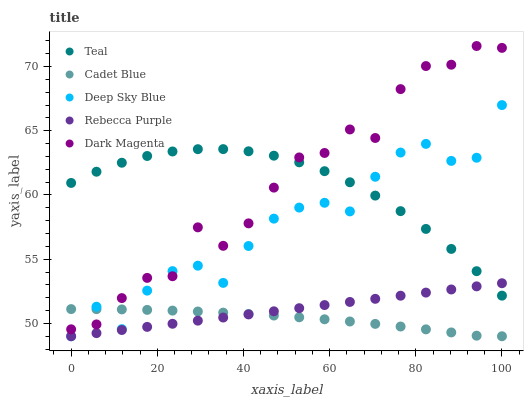Does Cadet Blue have the minimum area under the curve?
Answer yes or no. Yes. Does Dark Magenta have the maximum area under the curve?
Answer yes or no. Yes. Does Deep Sky Blue have the minimum area under the curve?
Answer yes or no. No. Does Deep Sky Blue have the maximum area under the curve?
Answer yes or no. No. Is Rebecca Purple the smoothest?
Answer yes or no. Yes. Is Dark Magenta the roughest?
Answer yes or no. Yes. Is Cadet Blue the smoothest?
Answer yes or no. No. Is Cadet Blue the roughest?
Answer yes or no. No. Does Cadet Blue have the lowest value?
Answer yes or no. Yes. Does Teal have the lowest value?
Answer yes or no. No. Does Dark Magenta have the highest value?
Answer yes or no. Yes. Does Deep Sky Blue have the highest value?
Answer yes or no. No. Is Cadet Blue less than Teal?
Answer yes or no. Yes. Is Teal greater than Cadet Blue?
Answer yes or no. Yes. Does Deep Sky Blue intersect Teal?
Answer yes or no. Yes. Is Deep Sky Blue less than Teal?
Answer yes or no. No. Is Deep Sky Blue greater than Teal?
Answer yes or no. No. Does Cadet Blue intersect Teal?
Answer yes or no. No. 